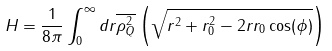Convert formula to latex. <formula><loc_0><loc_0><loc_500><loc_500>H = \frac { 1 } { 8 \pi } \int _ { 0 } ^ { \infty } d r \overline { \rho _ { Q } ^ { 2 } } \left ( \sqrt { r ^ { 2 } + r _ { 0 } ^ { 2 } - 2 r r _ { 0 } \cos ( \phi ) } \right )</formula> 